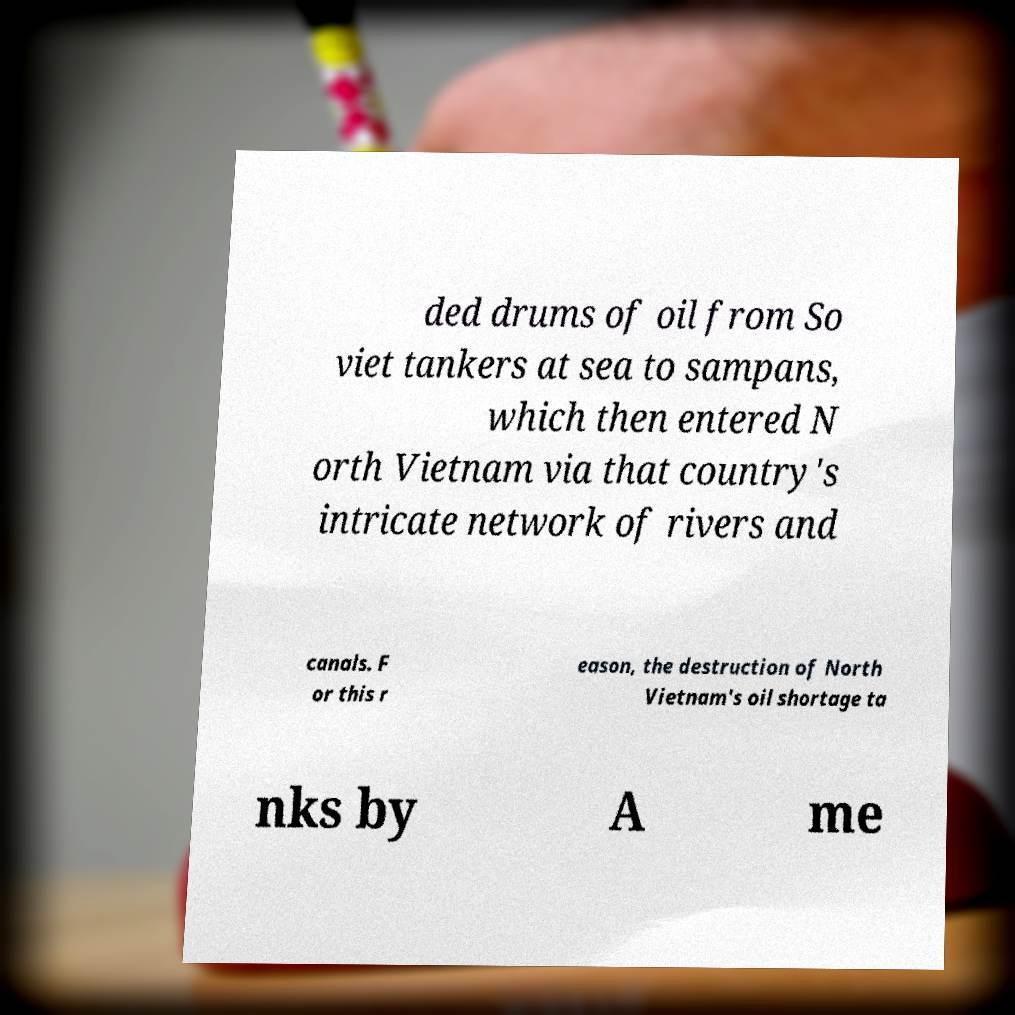What messages or text are displayed in this image? I need them in a readable, typed format. ded drums of oil from So viet tankers at sea to sampans, which then entered N orth Vietnam via that country's intricate network of rivers and canals. F or this r eason, the destruction of North Vietnam's oil shortage ta nks by A me 